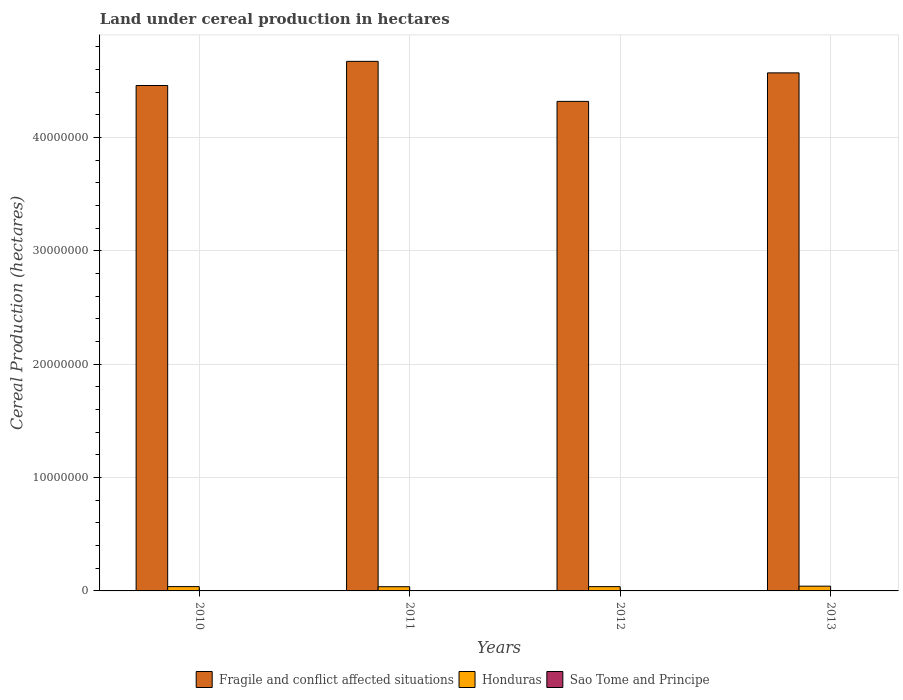How many different coloured bars are there?
Your answer should be compact. 3. How many groups of bars are there?
Keep it short and to the point. 4. Are the number of bars on each tick of the X-axis equal?
Provide a short and direct response. Yes. In how many cases, is the number of bars for a given year not equal to the number of legend labels?
Your answer should be very brief. 0. What is the land under cereal production in Fragile and conflict affected situations in 2012?
Your response must be concise. 4.32e+07. Across all years, what is the maximum land under cereal production in Sao Tome and Principe?
Your answer should be compact. 1350. Across all years, what is the minimum land under cereal production in Honduras?
Keep it short and to the point. 3.72e+05. What is the total land under cereal production in Fragile and conflict affected situations in the graph?
Provide a succinct answer. 1.80e+08. What is the difference between the land under cereal production in Sao Tome and Principe in 2010 and that in 2013?
Your answer should be very brief. -150. What is the difference between the land under cereal production in Sao Tome and Principe in 2012 and the land under cereal production in Honduras in 2013?
Your answer should be very brief. -4.19e+05. What is the average land under cereal production in Fragile and conflict affected situations per year?
Your response must be concise. 4.51e+07. In the year 2011, what is the difference between the land under cereal production in Honduras and land under cereal production in Sao Tome and Principe?
Your answer should be very brief. 3.71e+05. What is the ratio of the land under cereal production in Fragile and conflict affected situations in 2010 to that in 2013?
Make the answer very short. 0.98. Is the land under cereal production in Honduras in 2010 less than that in 2012?
Give a very brief answer. No. What is the difference between the highest and the second highest land under cereal production in Honduras?
Provide a short and direct response. 3.85e+04. What is the difference between the highest and the lowest land under cereal production in Honduras?
Your answer should be compact. 4.84e+04. In how many years, is the land under cereal production in Fragile and conflict affected situations greater than the average land under cereal production in Fragile and conflict affected situations taken over all years?
Ensure brevity in your answer.  2. What does the 2nd bar from the left in 2013 represents?
Provide a succinct answer. Honduras. What does the 3rd bar from the right in 2013 represents?
Give a very brief answer. Fragile and conflict affected situations. Are all the bars in the graph horizontal?
Provide a short and direct response. No. How many years are there in the graph?
Offer a very short reply. 4. Are the values on the major ticks of Y-axis written in scientific E-notation?
Give a very brief answer. No. Does the graph contain any zero values?
Your answer should be compact. No. Where does the legend appear in the graph?
Your response must be concise. Bottom center. How are the legend labels stacked?
Provide a short and direct response. Horizontal. What is the title of the graph?
Ensure brevity in your answer.  Land under cereal production in hectares. Does "Korea (Republic)" appear as one of the legend labels in the graph?
Make the answer very short. No. What is the label or title of the X-axis?
Provide a short and direct response. Years. What is the label or title of the Y-axis?
Keep it short and to the point. Cereal Production (hectares). What is the Cereal Production (hectares) in Fragile and conflict affected situations in 2010?
Make the answer very short. 4.46e+07. What is the Cereal Production (hectares) of Honduras in 2010?
Provide a succinct answer. 3.82e+05. What is the Cereal Production (hectares) in Sao Tome and Principe in 2010?
Your answer should be compact. 1200. What is the Cereal Production (hectares) of Fragile and conflict affected situations in 2011?
Provide a short and direct response. 4.67e+07. What is the Cereal Production (hectares) of Honduras in 2011?
Give a very brief answer. 3.72e+05. What is the Cereal Production (hectares) in Sao Tome and Principe in 2011?
Keep it short and to the point. 1300. What is the Cereal Production (hectares) in Fragile and conflict affected situations in 2012?
Provide a short and direct response. 4.32e+07. What is the Cereal Production (hectares) of Honduras in 2012?
Provide a short and direct response. 3.78e+05. What is the Cereal Production (hectares) of Sao Tome and Principe in 2012?
Provide a succinct answer. 1300. What is the Cereal Production (hectares) of Fragile and conflict affected situations in 2013?
Provide a short and direct response. 4.57e+07. What is the Cereal Production (hectares) in Honduras in 2013?
Offer a very short reply. 4.20e+05. What is the Cereal Production (hectares) of Sao Tome and Principe in 2013?
Keep it short and to the point. 1350. Across all years, what is the maximum Cereal Production (hectares) in Fragile and conflict affected situations?
Offer a very short reply. 4.67e+07. Across all years, what is the maximum Cereal Production (hectares) in Honduras?
Provide a short and direct response. 4.20e+05. Across all years, what is the maximum Cereal Production (hectares) in Sao Tome and Principe?
Your response must be concise. 1350. Across all years, what is the minimum Cereal Production (hectares) of Fragile and conflict affected situations?
Give a very brief answer. 4.32e+07. Across all years, what is the minimum Cereal Production (hectares) in Honduras?
Provide a succinct answer. 3.72e+05. Across all years, what is the minimum Cereal Production (hectares) of Sao Tome and Principe?
Offer a very short reply. 1200. What is the total Cereal Production (hectares) in Fragile and conflict affected situations in the graph?
Offer a very short reply. 1.80e+08. What is the total Cereal Production (hectares) of Honduras in the graph?
Ensure brevity in your answer.  1.55e+06. What is the total Cereal Production (hectares) in Sao Tome and Principe in the graph?
Offer a very short reply. 5150. What is the difference between the Cereal Production (hectares) in Fragile and conflict affected situations in 2010 and that in 2011?
Ensure brevity in your answer.  -2.13e+06. What is the difference between the Cereal Production (hectares) of Honduras in 2010 and that in 2011?
Ensure brevity in your answer.  9847. What is the difference between the Cereal Production (hectares) in Sao Tome and Principe in 2010 and that in 2011?
Keep it short and to the point. -100. What is the difference between the Cereal Production (hectares) of Fragile and conflict affected situations in 2010 and that in 2012?
Provide a short and direct response. 1.40e+06. What is the difference between the Cereal Production (hectares) in Honduras in 2010 and that in 2012?
Your answer should be very brief. 3766. What is the difference between the Cereal Production (hectares) in Sao Tome and Principe in 2010 and that in 2012?
Offer a very short reply. -100. What is the difference between the Cereal Production (hectares) of Fragile and conflict affected situations in 2010 and that in 2013?
Your answer should be very brief. -1.11e+06. What is the difference between the Cereal Production (hectares) of Honduras in 2010 and that in 2013?
Give a very brief answer. -3.85e+04. What is the difference between the Cereal Production (hectares) in Sao Tome and Principe in 2010 and that in 2013?
Your response must be concise. -150. What is the difference between the Cereal Production (hectares) of Fragile and conflict affected situations in 2011 and that in 2012?
Your response must be concise. 3.53e+06. What is the difference between the Cereal Production (hectares) in Honduras in 2011 and that in 2012?
Make the answer very short. -6081. What is the difference between the Cereal Production (hectares) of Fragile and conflict affected situations in 2011 and that in 2013?
Make the answer very short. 1.02e+06. What is the difference between the Cereal Production (hectares) in Honduras in 2011 and that in 2013?
Provide a short and direct response. -4.84e+04. What is the difference between the Cereal Production (hectares) of Fragile and conflict affected situations in 2012 and that in 2013?
Provide a succinct answer. -2.51e+06. What is the difference between the Cereal Production (hectares) in Honduras in 2012 and that in 2013?
Your response must be concise. -4.23e+04. What is the difference between the Cereal Production (hectares) of Sao Tome and Principe in 2012 and that in 2013?
Offer a terse response. -50. What is the difference between the Cereal Production (hectares) in Fragile and conflict affected situations in 2010 and the Cereal Production (hectares) in Honduras in 2011?
Provide a succinct answer. 4.42e+07. What is the difference between the Cereal Production (hectares) of Fragile and conflict affected situations in 2010 and the Cereal Production (hectares) of Sao Tome and Principe in 2011?
Offer a very short reply. 4.46e+07. What is the difference between the Cereal Production (hectares) in Honduras in 2010 and the Cereal Production (hectares) in Sao Tome and Principe in 2011?
Offer a very short reply. 3.80e+05. What is the difference between the Cereal Production (hectares) of Fragile and conflict affected situations in 2010 and the Cereal Production (hectares) of Honduras in 2012?
Keep it short and to the point. 4.42e+07. What is the difference between the Cereal Production (hectares) of Fragile and conflict affected situations in 2010 and the Cereal Production (hectares) of Sao Tome and Principe in 2012?
Make the answer very short. 4.46e+07. What is the difference between the Cereal Production (hectares) of Honduras in 2010 and the Cereal Production (hectares) of Sao Tome and Principe in 2012?
Your response must be concise. 3.80e+05. What is the difference between the Cereal Production (hectares) in Fragile and conflict affected situations in 2010 and the Cereal Production (hectares) in Honduras in 2013?
Your answer should be compact. 4.42e+07. What is the difference between the Cereal Production (hectares) in Fragile and conflict affected situations in 2010 and the Cereal Production (hectares) in Sao Tome and Principe in 2013?
Provide a succinct answer. 4.46e+07. What is the difference between the Cereal Production (hectares) in Honduras in 2010 and the Cereal Production (hectares) in Sao Tome and Principe in 2013?
Ensure brevity in your answer.  3.80e+05. What is the difference between the Cereal Production (hectares) of Fragile and conflict affected situations in 2011 and the Cereal Production (hectares) of Honduras in 2012?
Make the answer very short. 4.63e+07. What is the difference between the Cereal Production (hectares) of Fragile and conflict affected situations in 2011 and the Cereal Production (hectares) of Sao Tome and Principe in 2012?
Make the answer very short. 4.67e+07. What is the difference between the Cereal Production (hectares) of Honduras in 2011 and the Cereal Production (hectares) of Sao Tome and Principe in 2012?
Give a very brief answer. 3.71e+05. What is the difference between the Cereal Production (hectares) of Fragile and conflict affected situations in 2011 and the Cereal Production (hectares) of Honduras in 2013?
Give a very brief answer. 4.63e+07. What is the difference between the Cereal Production (hectares) in Fragile and conflict affected situations in 2011 and the Cereal Production (hectares) in Sao Tome and Principe in 2013?
Offer a terse response. 4.67e+07. What is the difference between the Cereal Production (hectares) of Honduras in 2011 and the Cereal Production (hectares) of Sao Tome and Principe in 2013?
Your response must be concise. 3.71e+05. What is the difference between the Cereal Production (hectares) in Fragile and conflict affected situations in 2012 and the Cereal Production (hectares) in Honduras in 2013?
Ensure brevity in your answer.  4.28e+07. What is the difference between the Cereal Production (hectares) in Fragile and conflict affected situations in 2012 and the Cereal Production (hectares) in Sao Tome and Principe in 2013?
Provide a succinct answer. 4.32e+07. What is the difference between the Cereal Production (hectares) of Honduras in 2012 and the Cereal Production (hectares) of Sao Tome and Principe in 2013?
Your answer should be very brief. 3.77e+05. What is the average Cereal Production (hectares) of Fragile and conflict affected situations per year?
Offer a very short reply. 4.51e+07. What is the average Cereal Production (hectares) of Honduras per year?
Your answer should be very brief. 3.88e+05. What is the average Cereal Production (hectares) in Sao Tome and Principe per year?
Provide a short and direct response. 1287.5. In the year 2010, what is the difference between the Cereal Production (hectares) of Fragile and conflict affected situations and Cereal Production (hectares) of Honduras?
Your answer should be very brief. 4.42e+07. In the year 2010, what is the difference between the Cereal Production (hectares) of Fragile and conflict affected situations and Cereal Production (hectares) of Sao Tome and Principe?
Your response must be concise. 4.46e+07. In the year 2010, what is the difference between the Cereal Production (hectares) in Honduras and Cereal Production (hectares) in Sao Tome and Principe?
Ensure brevity in your answer.  3.81e+05. In the year 2011, what is the difference between the Cereal Production (hectares) in Fragile and conflict affected situations and Cereal Production (hectares) in Honduras?
Provide a short and direct response. 4.64e+07. In the year 2011, what is the difference between the Cereal Production (hectares) of Fragile and conflict affected situations and Cereal Production (hectares) of Sao Tome and Principe?
Ensure brevity in your answer.  4.67e+07. In the year 2011, what is the difference between the Cereal Production (hectares) in Honduras and Cereal Production (hectares) in Sao Tome and Principe?
Provide a succinct answer. 3.71e+05. In the year 2012, what is the difference between the Cereal Production (hectares) of Fragile and conflict affected situations and Cereal Production (hectares) of Honduras?
Your answer should be very brief. 4.28e+07. In the year 2012, what is the difference between the Cereal Production (hectares) of Fragile and conflict affected situations and Cereal Production (hectares) of Sao Tome and Principe?
Your answer should be very brief. 4.32e+07. In the year 2012, what is the difference between the Cereal Production (hectares) in Honduras and Cereal Production (hectares) in Sao Tome and Principe?
Your answer should be compact. 3.77e+05. In the year 2013, what is the difference between the Cereal Production (hectares) of Fragile and conflict affected situations and Cereal Production (hectares) of Honduras?
Ensure brevity in your answer.  4.53e+07. In the year 2013, what is the difference between the Cereal Production (hectares) of Fragile and conflict affected situations and Cereal Production (hectares) of Sao Tome and Principe?
Ensure brevity in your answer.  4.57e+07. In the year 2013, what is the difference between the Cereal Production (hectares) in Honduras and Cereal Production (hectares) in Sao Tome and Principe?
Make the answer very short. 4.19e+05. What is the ratio of the Cereal Production (hectares) in Fragile and conflict affected situations in 2010 to that in 2011?
Your response must be concise. 0.95. What is the ratio of the Cereal Production (hectares) in Honduras in 2010 to that in 2011?
Your answer should be very brief. 1.03. What is the ratio of the Cereal Production (hectares) of Fragile and conflict affected situations in 2010 to that in 2012?
Provide a succinct answer. 1.03. What is the ratio of the Cereal Production (hectares) of Honduras in 2010 to that in 2012?
Make the answer very short. 1.01. What is the ratio of the Cereal Production (hectares) of Fragile and conflict affected situations in 2010 to that in 2013?
Give a very brief answer. 0.98. What is the ratio of the Cereal Production (hectares) in Honduras in 2010 to that in 2013?
Make the answer very short. 0.91. What is the ratio of the Cereal Production (hectares) of Fragile and conflict affected situations in 2011 to that in 2012?
Provide a succinct answer. 1.08. What is the ratio of the Cereal Production (hectares) in Honduras in 2011 to that in 2012?
Offer a very short reply. 0.98. What is the ratio of the Cereal Production (hectares) of Fragile and conflict affected situations in 2011 to that in 2013?
Give a very brief answer. 1.02. What is the ratio of the Cereal Production (hectares) of Honduras in 2011 to that in 2013?
Give a very brief answer. 0.88. What is the ratio of the Cereal Production (hectares) of Fragile and conflict affected situations in 2012 to that in 2013?
Give a very brief answer. 0.94. What is the ratio of the Cereal Production (hectares) of Honduras in 2012 to that in 2013?
Your answer should be very brief. 0.9. What is the ratio of the Cereal Production (hectares) in Sao Tome and Principe in 2012 to that in 2013?
Give a very brief answer. 0.96. What is the difference between the highest and the second highest Cereal Production (hectares) of Fragile and conflict affected situations?
Your response must be concise. 1.02e+06. What is the difference between the highest and the second highest Cereal Production (hectares) of Honduras?
Offer a very short reply. 3.85e+04. What is the difference between the highest and the second highest Cereal Production (hectares) of Sao Tome and Principe?
Ensure brevity in your answer.  50. What is the difference between the highest and the lowest Cereal Production (hectares) of Fragile and conflict affected situations?
Your response must be concise. 3.53e+06. What is the difference between the highest and the lowest Cereal Production (hectares) of Honduras?
Ensure brevity in your answer.  4.84e+04. What is the difference between the highest and the lowest Cereal Production (hectares) of Sao Tome and Principe?
Your response must be concise. 150. 